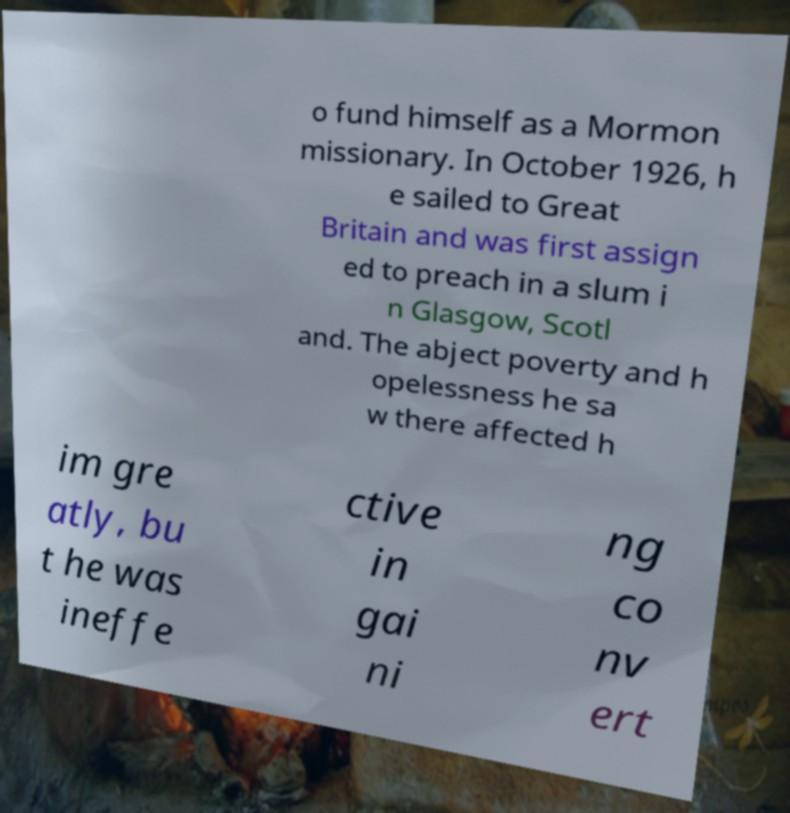There's text embedded in this image that I need extracted. Can you transcribe it verbatim? o fund himself as a Mormon missionary. In October 1926, h e sailed to Great Britain and was first assign ed to preach in a slum i n Glasgow, Scotl and. The abject poverty and h opelessness he sa w there affected h im gre atly, bu t he was ineffe ctive in gai ni ng co nv ert 